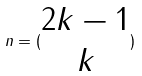Convert formula to latex. <formula><loc_0><loc_0><loc_500><loc_500>n = ( \begin{matrix} 2 k - 1 \\ k \end{matrix} )</formula> 